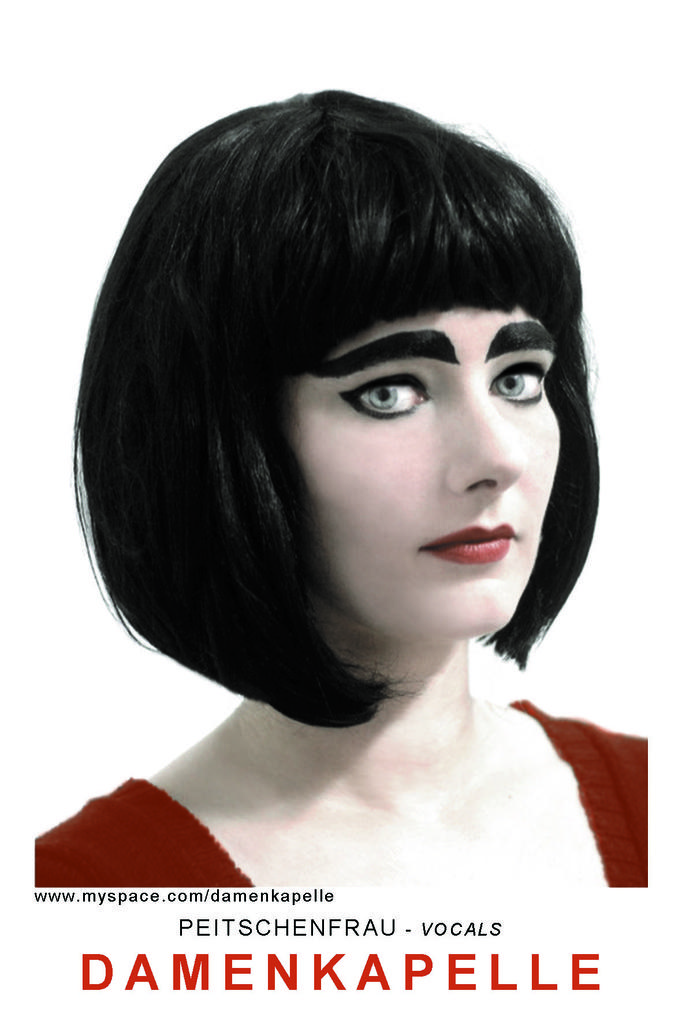What is depicted in the pictures in the image? There are pictures of a woman in the image that depict a woman. Can you describe any additional information that is present in the image? Yes, there is text at the bottom of the image. What scent can be detected from the hen in the image? There is no hen present in the image, so it is not possible to determine its scent. 